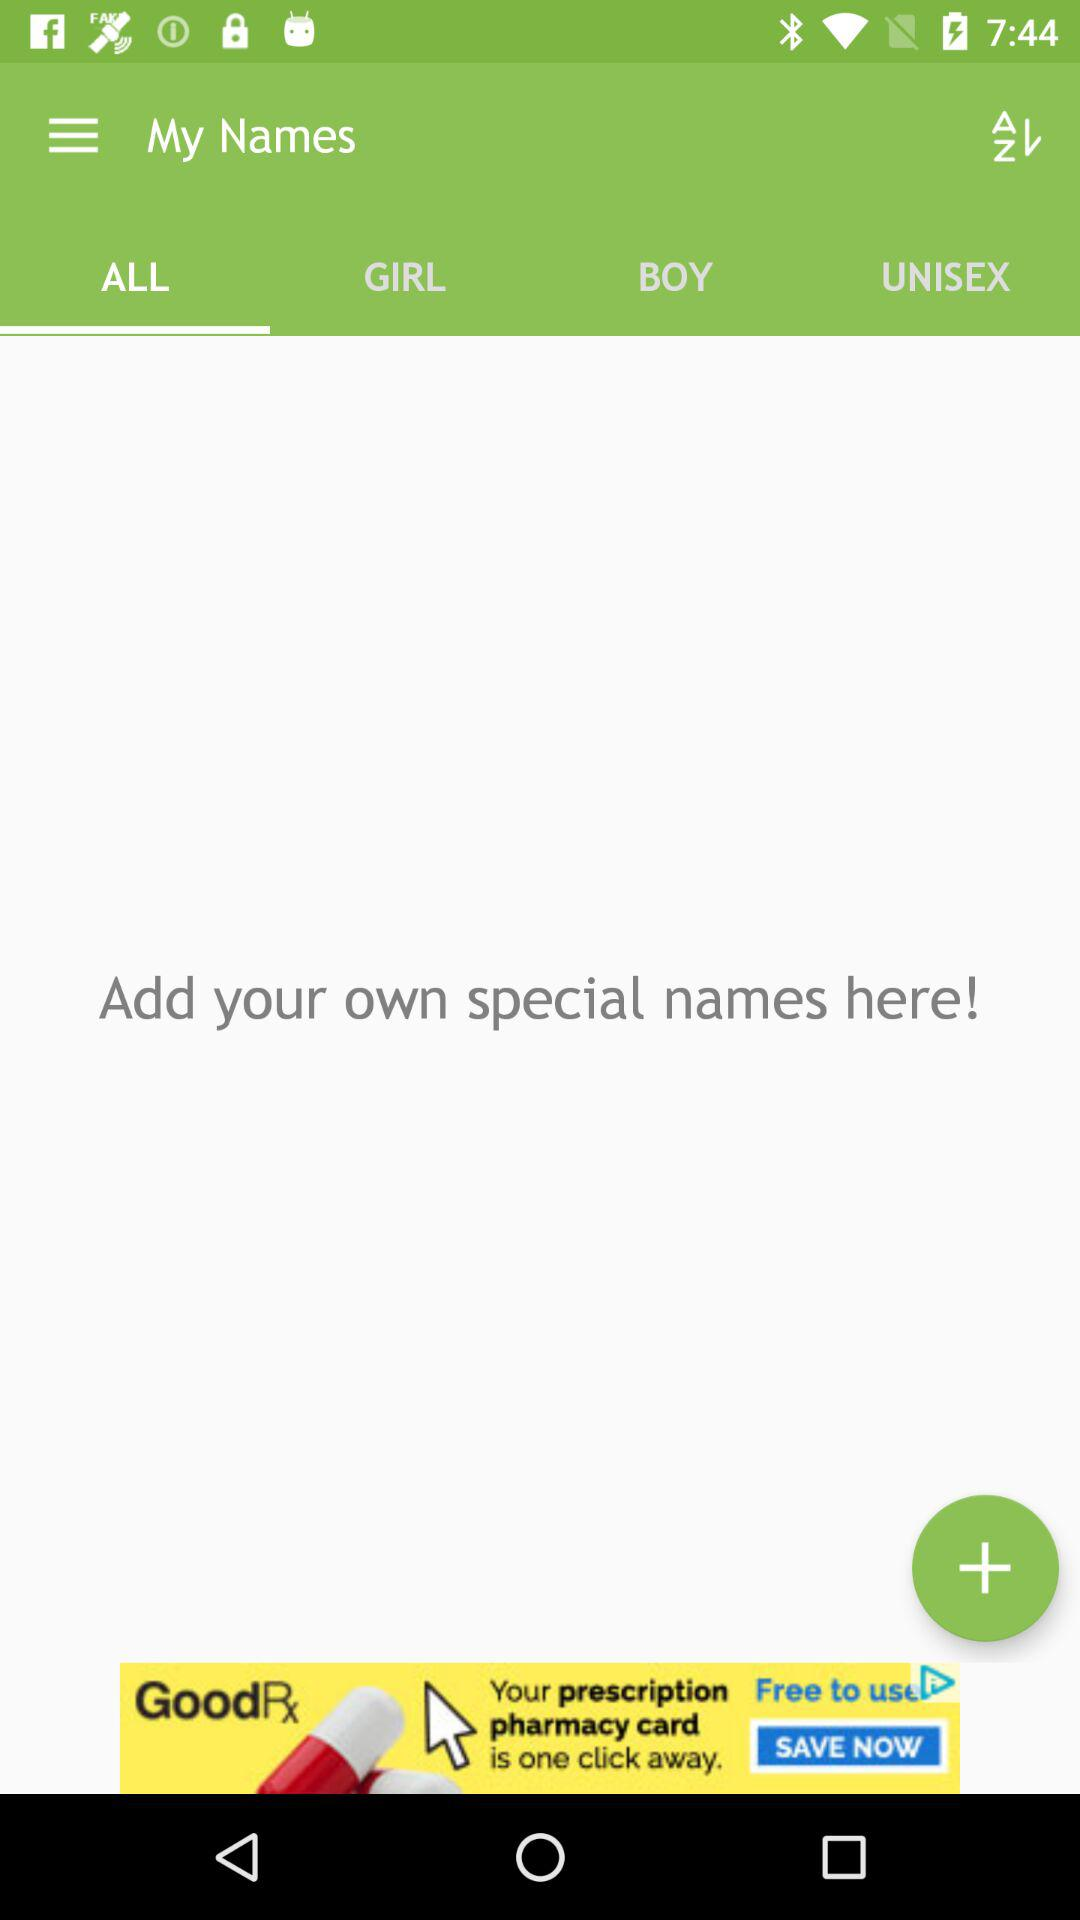What tab is open? The open tab is "ALL". 